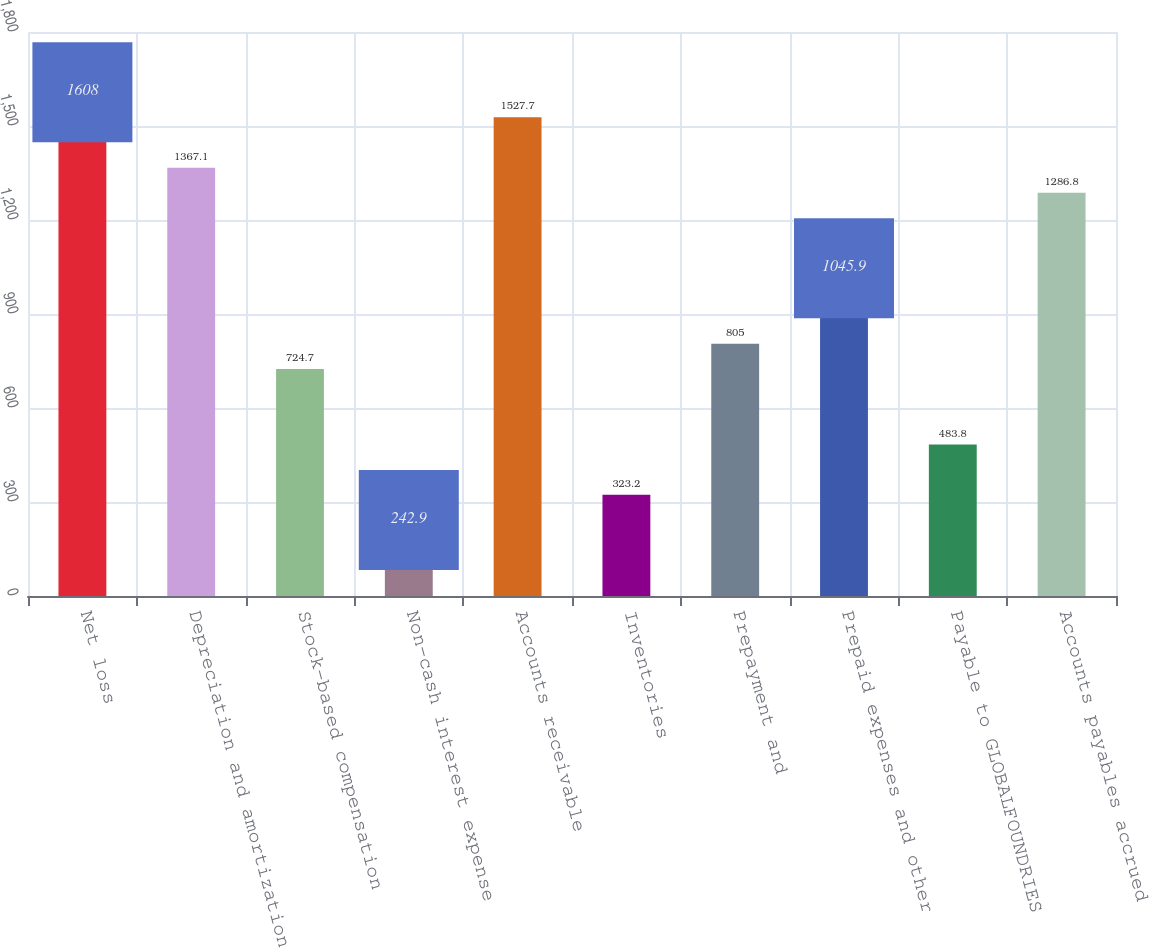Convert chart. <chart><loc_0><loc_0><loc_500><loc_500><bar_chart><fcel>Net loss<fcel>Depreciation and amortization<fcel>Stock-based compensation<fcel>Non-cash interest expense<fcel>Accounts receivable<fcel>Inventories<fcel>Prepayment and<fcel>Prepaid expenses and other<fcel>Payable to GLOBALFOUNDRIES<fcel>Accounts payables accrued<nl><fcel>1608<fcel>1367.1<fcel>724.7<fcel>242.9<fcel>1527.7<fcel>323.2<fcel>805<fcel>1045.9<fcel>483.8<fcel>1286.8<nl></chart> 